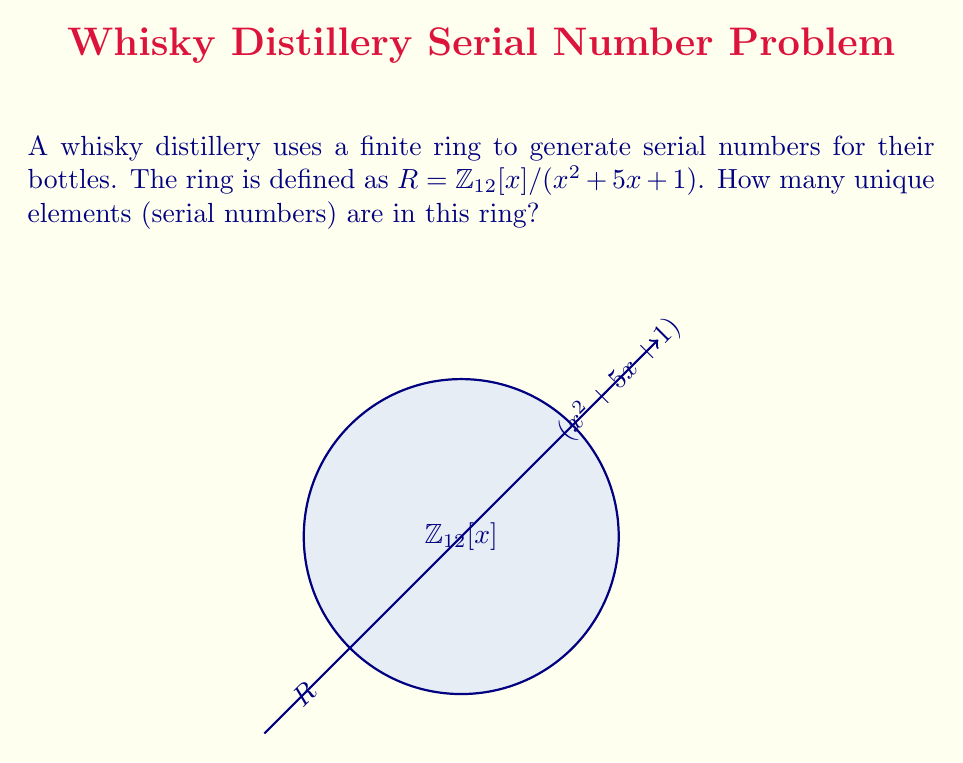Can you answer this question? To determine the number of unique elements in the ring $R = \mathbb{Z}_{12}[x] / (x^2 + 5x + 1)$, we need to follow these steps:

1) First, we need to understand what this notation means. $\mathbb{Z}_{12}[x]$ is the ring of polynomials with coefficients from $\mathbb{Z}_{12}$ (integers modulo 12). We're then taking the quotient of this ring by the ideal generated by $x^2 + 5x + 1$.

2) In a quotient ring, two polynomials are considered equivalent if their difference is divisible by the polynomial we're quotienting by (in this case, $x^2 + 5x + 1$).

3) This means that any polynomial in our ring can be reduced to the form $ax + b$, where $a$ and $b$ are elements of $\mathbb{Z}_{12}$. Any higher degree terms can be reduced using the relation $x^2 \equiv -5x - 1 \pmod{12}$.

4) Now, we need to count how many unique polynomials of the form $ax + b$ we can have:
   - $a$ can be any element of $\mathbb{Z}_{12}$, so there are 12 choices for $a$.
   - For each choice of $a$, $b$ can also be any element of $\mathbb{Z}_{12}$, so there are 12 choices for $b$.

5) By the multiplication principle, the total number of unique elements in the ring is therefore $12 \times 12 = 144$.
Answer: 144 